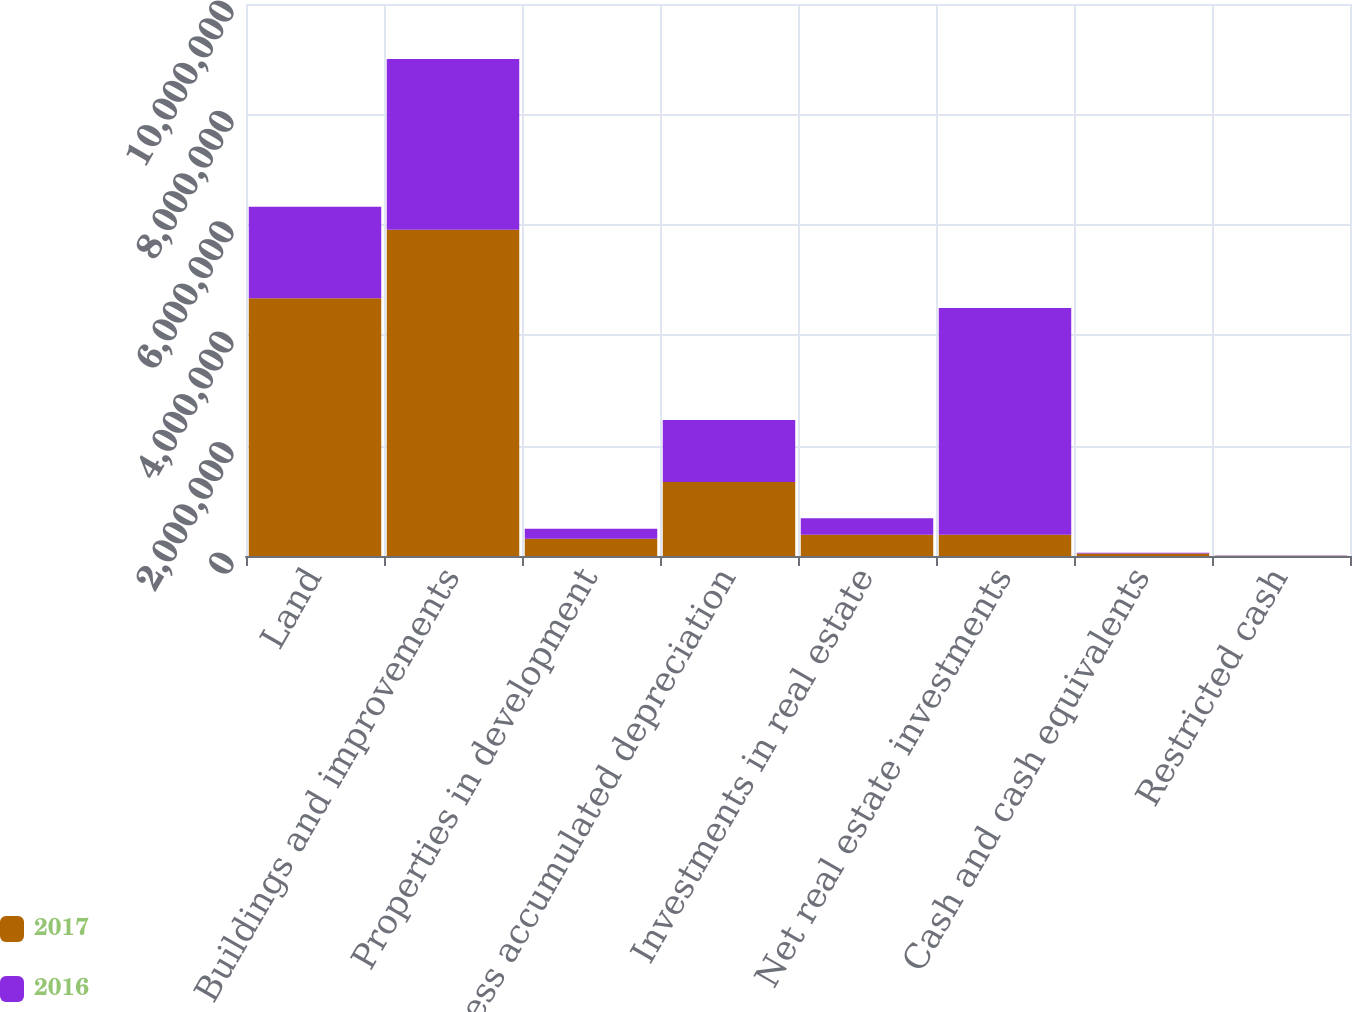Convert chart to OTSL. <chart><loc_0><loc_0><loc_500><loc_500><stacked_bar_chart><ecel><fcel>Land<fcel>Buildings and improvements<fcel>Properties in development<fcel>Less accumulated depreciation<fcel>Investments in real estate<fcel>Net real estate investments<fcel>Cash and cash equivalents<fcel>Restricted cash<nl><fcel>2017<fcel>4.66774e+06<fcel>5.91069e+06<fcel>314391<fcel>1.33977e+06<fcel>386304<fcel>386304<fcel>45370<fcel>4011<nl><fcel>2016<fcel>1.66042e+06<fcel>3.0922e+06<fcel>180878<fcel>1.12439e+06<fcel>296699<fcel>4.10581e+06<fcel>13256<fcel>4623<nl></chart> 